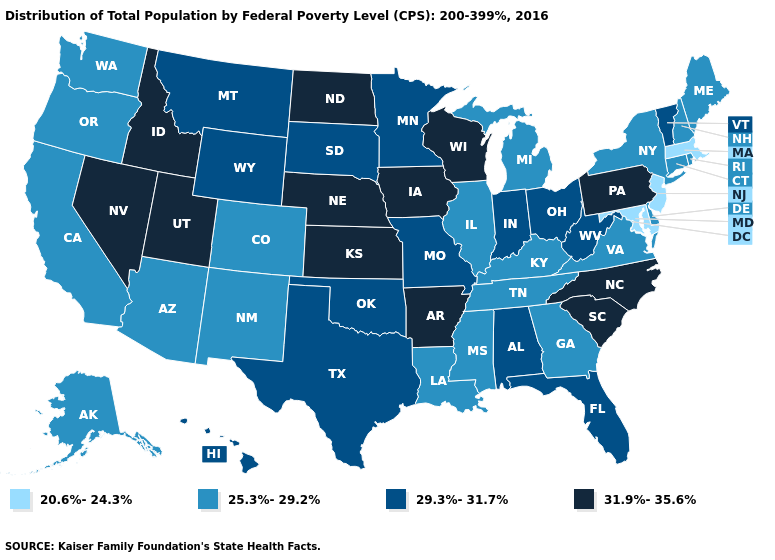Name the states that have a value in the range 25.3%-29.2%?
Keep it brief. Alaska, Arizona, California, Colorado, Connecticut, Delaware, Georgia, Illinois, Kentucky, Louisiana, Maine, Michigan, Mississippi, New Hampshire, New Mexico, New York, Oregon, Rhode Island, Tennessee, Virginia, Washington. Name the states that have a value in the range 29.3%-31.7%?
Be succinct. Alabama, Florida, Hawaii, Indiana, Minnesota, Missouri, Montana, Ohio, Oklahoma, South Dakota, Texas, Vermont, West Virginia, Wyoming. Does Connecticut have a higher value than New Jersey?
Keep it brief. Yes. Name the states that have a value in the range 31.9%-35.6%?
Quick response, please. Arkansas, Idaho, Iowa, Kansas, Nebraska, Nevada, North Carolina, North Dakota, Pennsylvania, South Carolina, Utah, Wisconsin. Name the states that have a value in the range 25.3%-29.2%?
Short answer required. Alaska, Arizona, California, Colorado, Connecticut, Delaware, Georgia, Illinois, Kentucky, Louisiana, Maine, Michigan, Mississippi, New Hampshire, New Mexico, New York, Oregon, Rhode Island, Tennessee, Virginia, Washington. Name the states that have a value in the range 29.3%-31.7%?
Be succinct. Alabama, Florida, Hawaii, Indiana, Minnesota, Missouri, Montana, Ohio, Oklahoma, South Dakota, Texas, Vermont, West Virginia, Wyoming. Name the states that have a value in the range 25.3%-29.2%?
Write a very short answer. Alaska, Arizona, California, Colorado, Connecticut, Delaware, Georgia, Illinois, Kentucky, Louisiana, Maine, Michigan, Mississippi, New Hampshire, New Mexico, New York, Oregon, Rhode Island, Tennessee, Virginia, Washington. What is the value of Florida?
Keep it brief. 29.3%-31.7%. Does Illinois have the same value as Michigan?
Short answer required. Yes. Does West Virginia have the same value as Wisconsin?
Concise answer only. No. Name the states that have a value in the range 31.9%-35.6%?
Concise answer only. Arkansas, Idaho, Iowa, Kansas, Nebraska, Nevada, North Carolina, North Dakota, Pennsylvania, South Carolina, Utah, Wisconsin. What is the value of Pennsylvania?
Give a very brief answer. 31.9%-35.6%. What is the value of Colorado?
Quick response, please. 25.3%-29.2%. What is the value of Missouri?
Write a very short answer. 29.3%-31.7%. Which states have the lowest value in the Northeast?
Concise answer only. Massachusetts, New Jersey. 